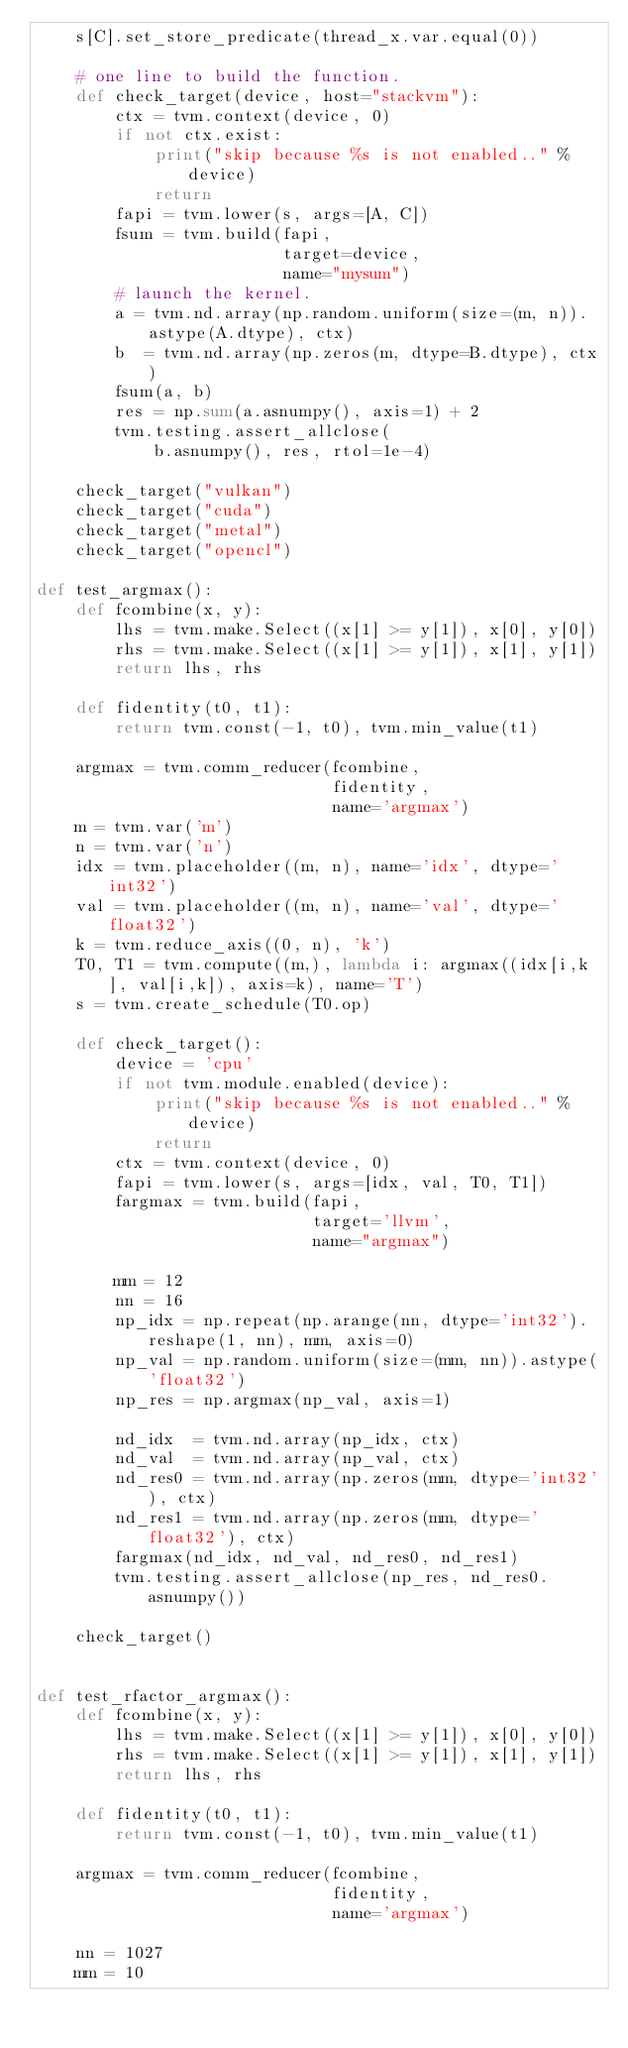Convert code to text. <code><loc_0><loc_0><loc_500><loc_500><_Python_>    s[C].set_store_predicate(thread_x.var.equal(0))

    # one line to build the function.
    def check_target(device, host="stackvm"):
        ctx = tvm.context(device, 0)
        if not ctx.exist:
            print("skip because %s is not enabled.." % device)
            return
        fapi = tvm.lower(s, args=[A, C])
        fsum = tvm.build(fapi,
                         target=device,
                         name="mysum")
        # launch the kernel.
        a = tvm.nd.array(np.random.uniform(size=(m, n)).astype(A.dtype), ctx)
        b  = tvm.nd.array(np.zeros(m, dtype=B.dtype), ctx)
        fsum(a, b)
        res = np.sum(a.asnumpy(), axis=1) + 2
        tvm.testing.assert_allclose(
            b.asnumpy(), res, rtol=1e-4)

    check_target("vulkan")
    check_target("cuda")
    check_target("metal")
    check_target("opencl")

def test_argmax():
    def fcombine(x, y):
        lhs = tvm.make.Select((x[1] >= y[1]), x[0], y[0])
        rhs = tvm.make.Select((x[1] >= y[1]), x[1], y[1])
        return lhs, rhs

    def fidentity(t0, t1):
        return tvm.const(-1, t0), tvm.min_value(t1)

    argmax = tvm.comm_reducer(fcombine,
                              fidentity,
                              name='argmax')
    m = tvm.var('m')
    n = tvm.var('n')
    idx = tvm.placeholder((m, n), name='idx', dtype='int32')
    val = tvm.placeholder((m, n), name='val', dtype='float32')
    k = tvm.reduce_axis((0, n), 'k')
    T0, T1 = tvm.compute((m,), lambda i: argmax((idx[i,k], val[i,k]), axis=k), name='T')
    s = tvm.create_schedule(T0.op)

    def check_target():
        device = 'cpu'
        if not tvm.module.enabled(device):
            print("skip because %s is not enabled.." % device)
            return
        ctx = tvm.context(device, 0)
        fapi = tvm.lower(s, args=[idx, val, T0, T1])
        fargmax = tvm.build(fapi,
                            target='llvm',
                            name="argmax")

        mm = 12
        nn = 16
        np_idx = np.repeat(np.arange(nn, dtype='int32').reshape(1, nn), mm, axis=0)
        np_val = np.random.uniform(size=(mm, nn)).astype('float32')
        np_res = np.argmax(np_val, axis=1)

        nd_idx  = tvm.nd.array(np_idx, ctx)
        nd_val  = tvm.nd.array(np_val, ctx)
        nd_res0 = tvm.nd.array(np.zeros(mm, dtype='int32'), ctx)
        nd_res1 = tvm.nd.array(np.zeros(mm, dtype='float32'), ctx)
        fargmax(nd_idx, nd_val, nd_res0, nd_res1)
        tvm.testing.assert_allclose(np_res, nd_res0.asnumpy())

    check_target()


def test_rfactor_argmax():
    def fcombine(x, y):
        lhs = tvm.make.Select((x[1] >= y[1]), x[0], y[0])
        rhs = tvm.make.Select((x[1] >= y[1]), x[1], y[1])
        return lhs, rhs

    def fidentity(t0, t1):
        return tvm.const(-1, t0), tvm.min_value(t1)

    argmax = tvm.comm_reducer(fcombine,
                              fidentity,
                              name='argmax')

    nn = 1027
    mm = 10</code> 